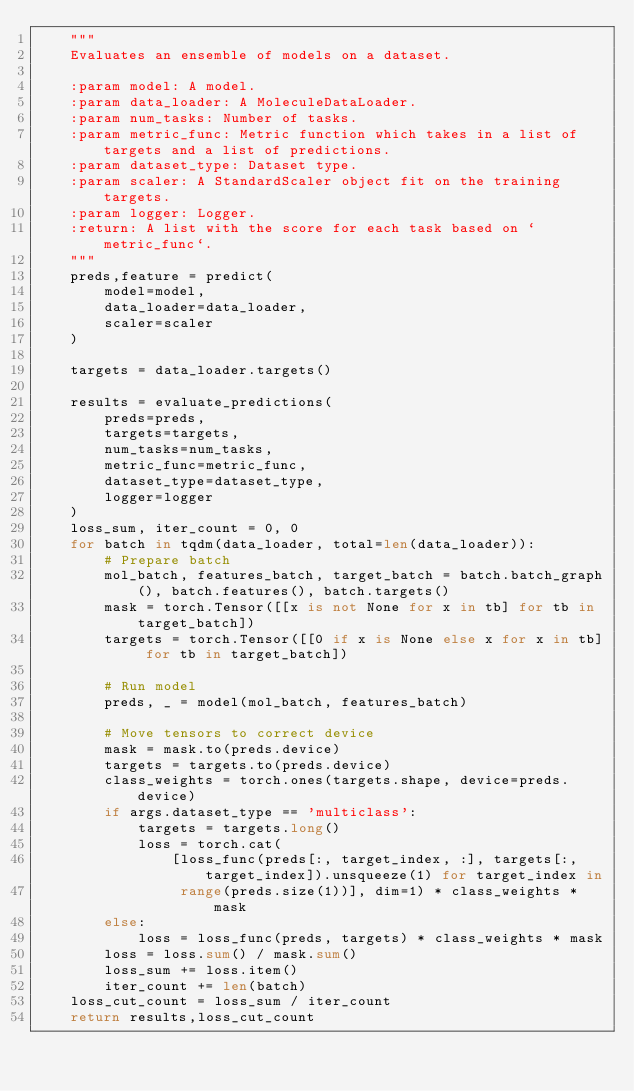Convert code to text. <code><loc_0><loc_0><loc_500><loc_500><_Python_>    """
    Evaluates an ensemble of models on a dataset.

    :param model: A model.
    :param data_loader: A MoleculeDataLoader.
    :param num_tasks: Number of tasks.
    :param metric_func: Metric function which takes in a list of targets and a list of predictions.
    :param dataset_type: Dataset type.
    :param scaler: A StandardScaler object fit on the training targets.
    :param logger: Logger.
    :return: A list with the score for each task based on `metric_func`.
    """
    preds,feature = predict(
        model=model,
        data_loader=data_loader,
        scaler=scaler
    )

    targets = data_loader.targets()

    results = evaluate_predictions(
        preds=preds,
        targets=targets,
        num_tasks=num_tasks,
        metric_func=metric_func,
        dataset_type=dataset_type,
        logger=logger
    )
    loss_sum, iter_count = 0, 0
    for batch in tqdm(data_loader, total=len(data_loader)):
        # Prepare batch
        mol_batch, features_batch, target_batch = batch.batch_graph(), batch.features(), batch.targets()
        mask = torch.Tensor([[x is not None for x in tb] for tb in target_batch])
        targets = torch.Tensor([[0 if x is None else x for x in tb] for tb in target_batch])

        # Run model
        preds, _ = model(mol_batch, features_batch)

        # Move tensors to correct device
        mask = mask.to(preds.device)
        targets = targets.to(preds.device)
        class_weights = torch.ones(targets.shape, device=preds.device)
        if args.dataset_type == 'multiclass':
            targets = targets.long()
            loss = torch.cat(
                [loss_func(preds[:, target_index, :], targets[:, target_index]).unsqueeze(1) for target_index in
                 range(preds.size(1))], dim=1) * class_weights * mask
        else:
            loss = loss_func(preds, targets) * class_weights * mask
        loss = loss.sum() / mask.sum()
        loss_sum += loss.item()
        iter_count += len(batch)
    loss_cut_count = loss_sum / iter_count
    return results,loss_cut_count



</code> 